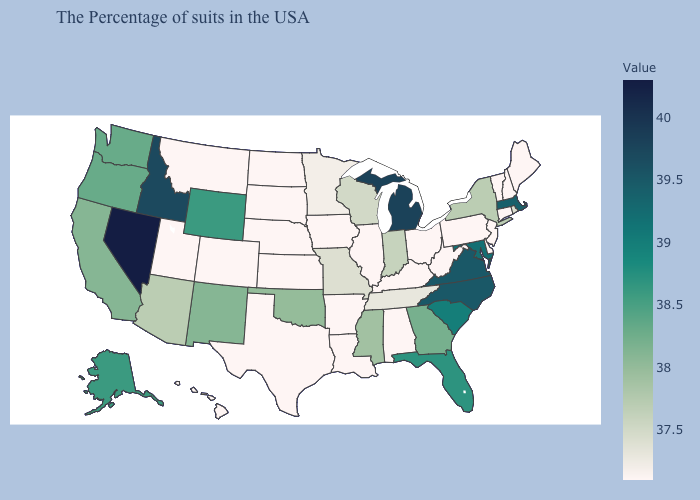Among the states that border Montana , does Wyoming have the lowest value?
Concise answer only. No. Does Virginia have a higher value than Nevada?
Short answer required. No. Does Alaska have the highest value in the USA?
Give a very brief answer. No. Is the legend a continuous bar?
Keep it brief. Yes. Which states have the highest value in the USA?
Concise answer only. Nevada. Among the states that border Maryland , does Virginia have the lowest value?
Short answer required. No. Among the states that border Oregon , which have the highest value?
Keep it brief. Nevada. Does the map have missing data?
Concise answer only. No. 